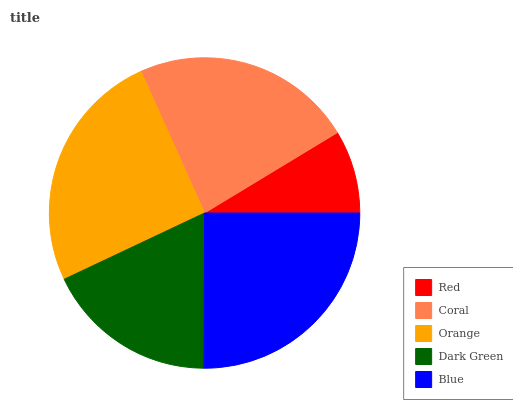Is Red the minimum?
Answer yes or no. Yes. Is Orange the maximum?
Answer yes or no. Yes. Is Coral the minimum?
Answer yes or no. No. Is Coral the maximum?
Answer yes or no. No. Is Coral greater than Red?
Answer yes or no. Yes. Is Red less than Coral?
Answer yes or no. Yes. Is Red greater than Coral?
Answer yes or no. No. Is Coral less than Red?
Answer yes or no. No. Is Coral the high median?
Answer yes or no. Yes. Is Coral the low median?
Answer yes or no. Yes. Is Red the high median?
Answer yes or no. No. Is Dark Green the low median?
Answer yes or no. No. 